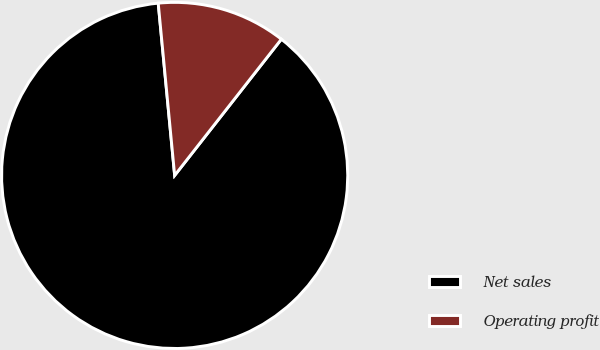Convert chart to OTSL. <chart><loc_0><loc_0><loc_500><loc_500><pie_chart><fcel>Net sales<fcel>Operating profit<nl><fcel>87.91%<fcel>12.09%<nl></chart> 